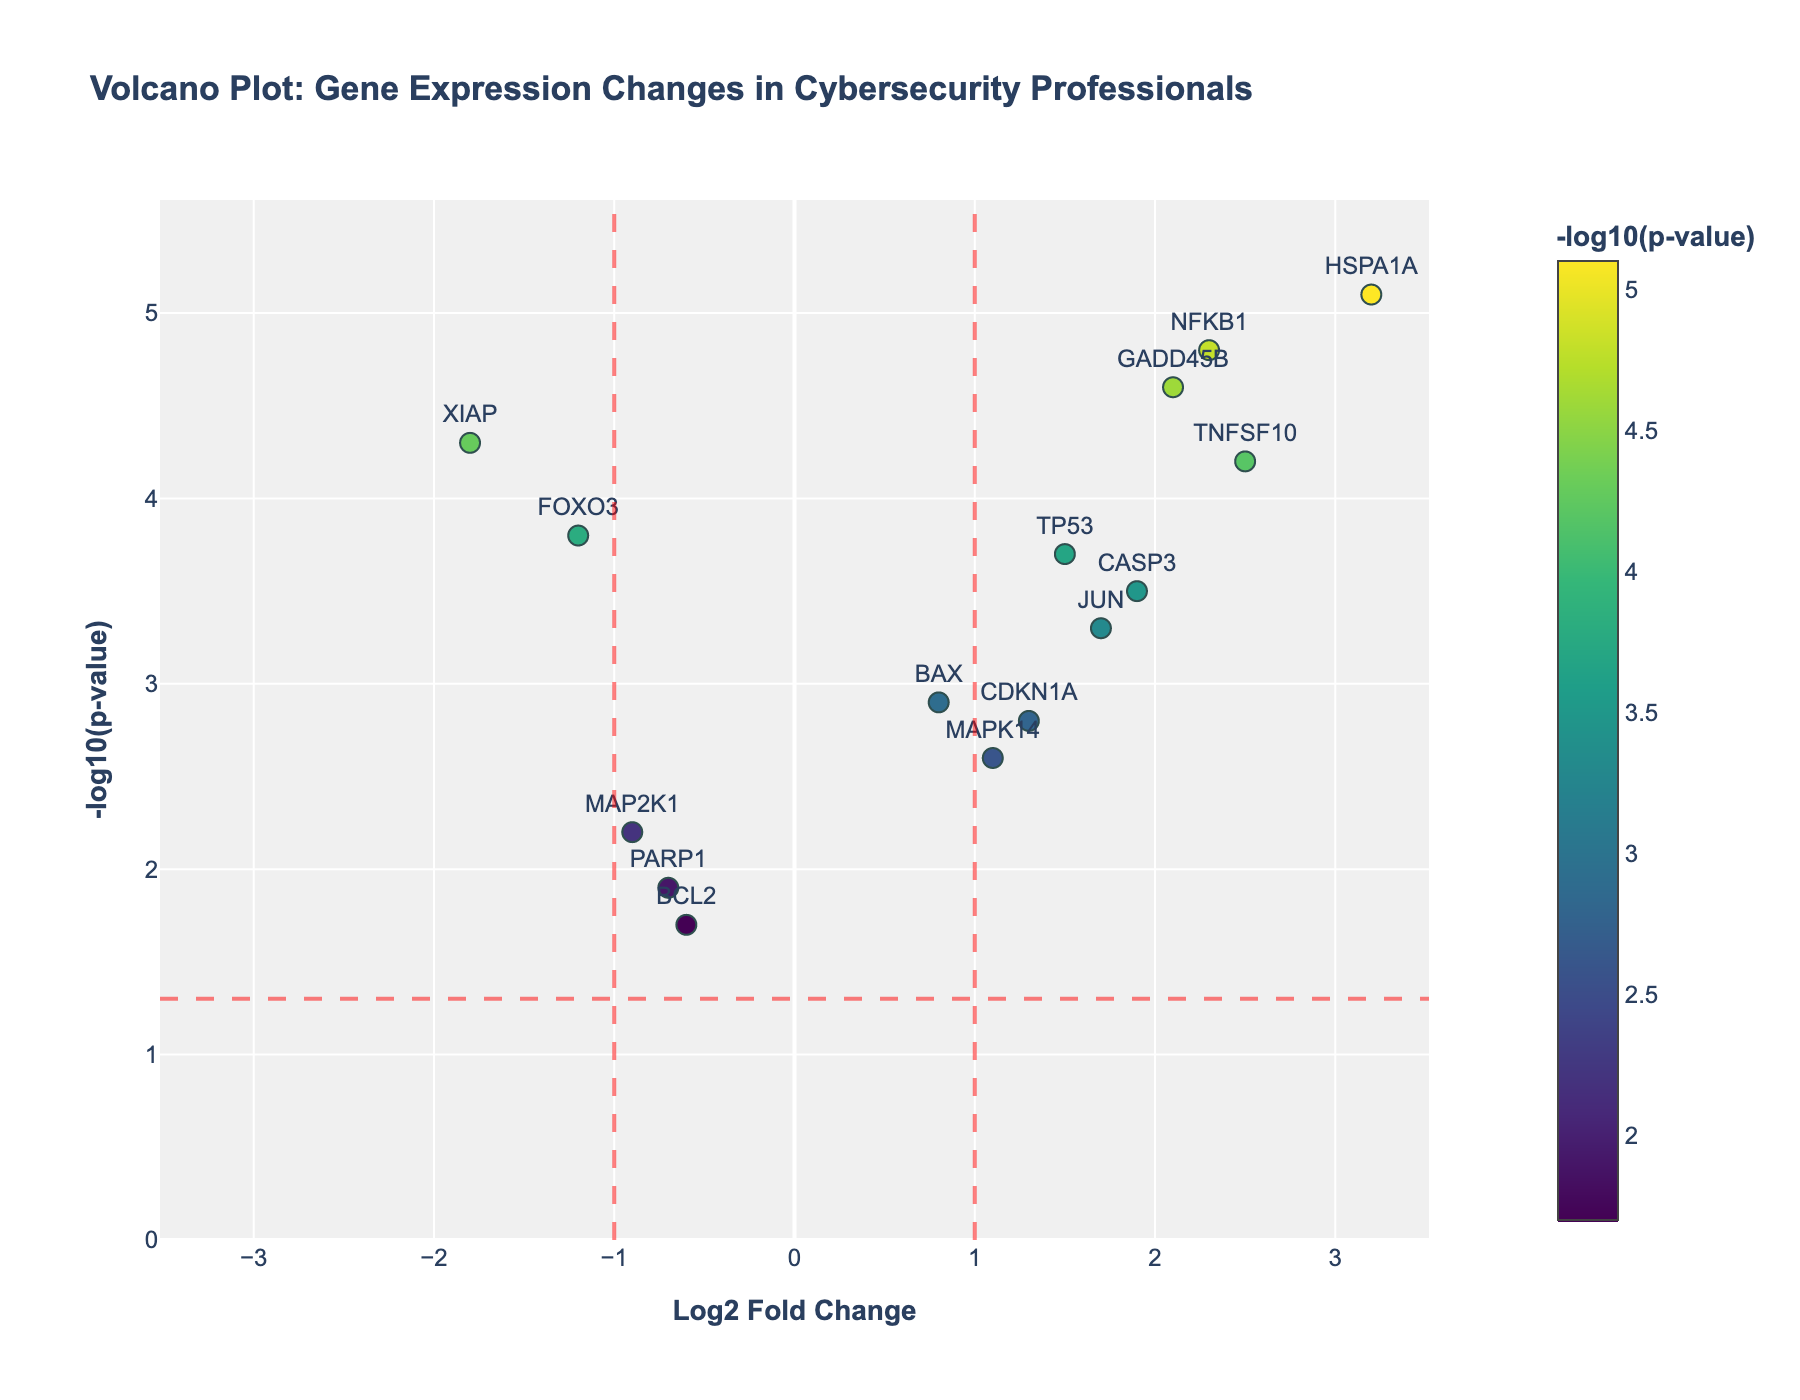Which gene has the highest -log10(p-value)? In the plot, the -log10(p-value) is represented by the y-axis. By looking at the highest point on the y-axis, you can see that HSPA1A has the highest value of 5.1.
Answer: HSPA1A What is the significance threshold for the -log10(p-value)? The plot includes a horizontal dashed red line that indicates the significance threshold. This line is at y = -log10(0.05), which is calculated as p-value threshold.
Answer: 1.3 Which genes have a Log2 Fold Change greater than 2? To find this, analyze the x-axis for points located to the right of 2. The data points representing TNFSF10, HSPA1A, and NFKB1 meet this criterion.
Answer: TNFSF10, HSPA1A, NFKB1 How many genes are significantly upregulated (Log2FC > 1 and p-value < 0.05)? To be significantly upregulated, genes need to have Log2 Fold Change > 1 and -log10(p-value) > 1.3. According to the plot, the genes that satisfy both conditions are TNFSF10, CASP3, GADD45B, HSPA1A, JUN, NFKB1, and TP53.
Answer: 7 Which gene with a Log2 Fold Change less than -1 has the highest significance? To answer this, examine the genes with x values less than -1 and find the one with the highest y value (highest -log10(p-value)). By inspection, XIAP has a Log2 Fold Change of -1.8 and a -log10(p-value) of 4.3.
Answer: XIAP What is the range of the Log2 Fold Change represented in the plot? Identify the minimum and maximum Log2 Fold Change values in the plot. By examining the x-axis, the minimum is -1.8 (XIAP) and the maximum is 3.2 (HSPA1A).
Answer: -1.8 to 3.2 Compare the significance of FOXO3 and MAP2K1. Which one is more significant? Look at the -log10(p-value) for both genes. FOXO3 has a -log10(p-value) of 3.8, while MAP2K1 has a -log10(p-value) of 2.2. Since 3.8 > 2.2, FOXO3 is more significant.
Answer: FOXO3 What are the coordinates (Log2 Fold Change, -log10[p-value]) of the gene BCL2 in the plot? Find the data point labeled with BCL2 and note its x and y values. For BCL2, the coordinates are (-0.6, 1.7).
Answer: (-0.6, 1.7) 